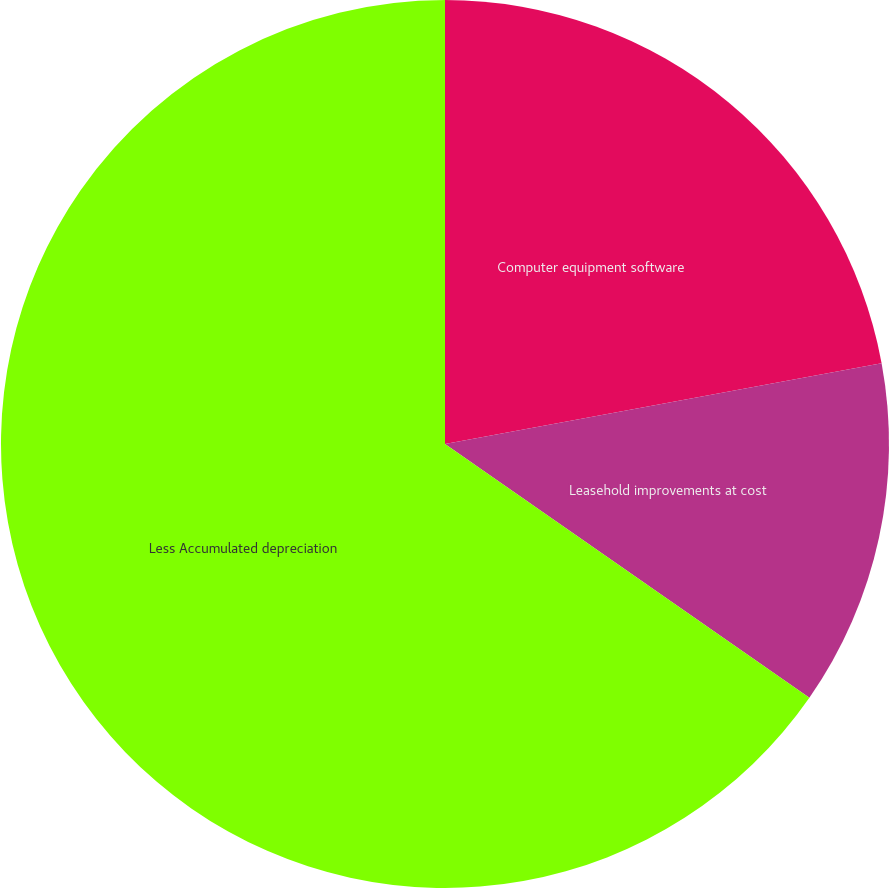Convert chart to OTSL. <chart><loc_0><loc_0><loc_500><loc_500><pie_chart><fcel>Computer equipment software<fcel>Leasehold improvements at cost<fcel>Less Accumulated depreciation<nl><fcel>22.09%<fcel>12.59%<fcel>65.32%<nl></chart> 